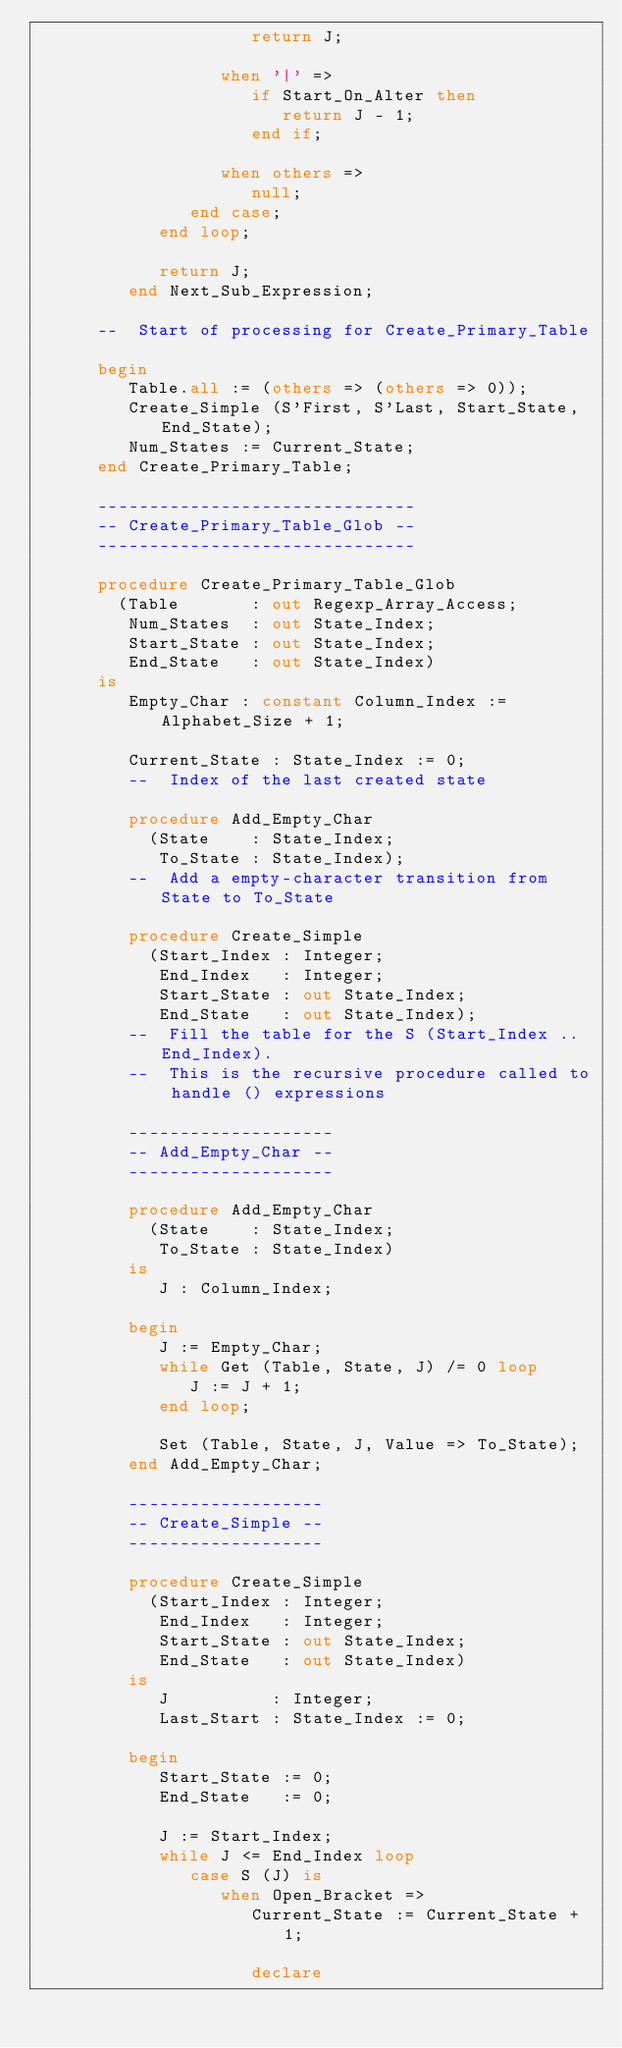Convert code to text. <code><loc_0><loc_0><loc_500><loc_500><_Ada_>                     return J;

                  when '|' =>
                     if Start_On_Alter then
                        return J - 1;
                     end if;

                  when others =>
                     null;
               end case;
            end loop;

            return J;
         end Next_Sub_Expression;

      --  Start of processing for Create_Primary_Table

      begin
         Table.all := (others => (others => 0));
         Create_Simple (S'First, S'Last, Start_State, End_State);
         Num_States := Current_State;
      end Create_Primary_Table;

      -------------------------------
      -- Create_Primary_Table_Glob --
      -------------------------------

      procedure Create_Primary_Table_Glob
        (Table       : out Regexp_Array_Access;
         Num_States  : out State_Index;
         Start_State : out State_Index;
         End_State   : out State_Index)
      is
         Empty_Char : constant Column_Index := Alphabet_Size + 1;

         Current_State : State_Index := 0;
         --  Index of the last created state

         procedure Add_Empty_Char
           (State    : State_Index;
            To_State : State_Index);
         --  Add a empty-character transition from State to To_State

         procedure Create_Simple
           (Start_Index : Integer;
            End_Index   : Integer;
            Start_State : out State_Index;
            End_State   : out State_Index);
         --  Fill the table for the S (Start_Index .. End_Index).
         --  This is the recursive procedure called to handle () expressions

         --------------------
         -- Add_Empty_Char --
         --------------------

         procedure Add_Empty_Char
           (State    : State_Index;
            To_State : State_Index)
         is
            J : Column_Index;

         begin
            J := Empty_Char;
            while Get (Table, State, J) /= 0 loop
               J := J + 1;
            end loop;

            Set (Table, State, J, Value => To_State);
         end Add_Empty_Char;

         -------------------
         -- Create_Simple --
         -------------------

         procedure Create_Simple
           (Start_Index : Integer;
            End_Index   : Integer;
            Start_State : out State_Index;
            End_State   : out State_Index)
         is
            J          : Integer;
            Last_Start : State_Index := 0;

         begin
            Start_State := 0;
            End_State   := 0;

            J := Start_Index;
            while J <= End_Index loop
               case S (J) is
                  when Open_Bracket =>
                     Current_State := Current_State + 1;

                     declare</code> 